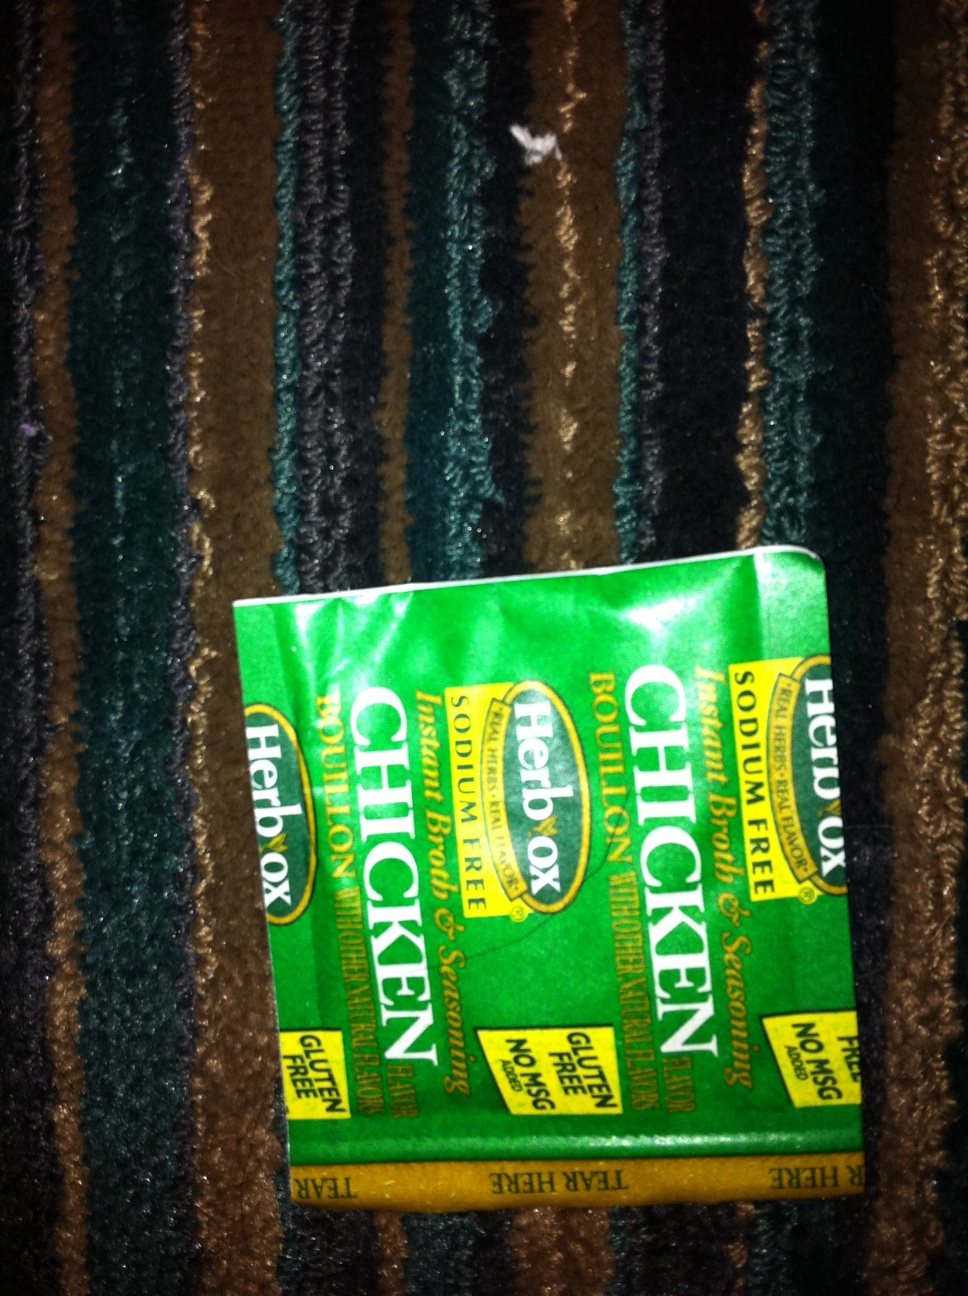Could you tell a story involving this bouillon? In a small village nestled among rolling hills, there was a renowned chef named Clara who was famous for her heartwarming soups. Every evening, the aroma of her creations would fill the air, drawing villagers and travelers alike to her cozy restaurant, ‘Clara's Comfort.’ Her secret ingredient was Herbox Chicken Bouillon, known only to her closest confidants.

One winter, a terrible snowstorm struck, and the villagers were confined to their homes. Seeing the hardship around her, Clara decided to make a giant pot of her special chicken soup using Herbox Chicken Bouillon to lift everyone’s spirits. She trudged through the snow, delivering steaming bowls of soup to each household. People were amazed at how a simple broth could bring so much warmth and joy.

The storm eventually passed, but the memory of Clara’s heartwarming soup lived on in the village forever. People often gathered at ‘Clara's Comfort’ to share a bowl of soup and reminisce, knowing that a simple packet of bouillon could create lasting connections and memories. 